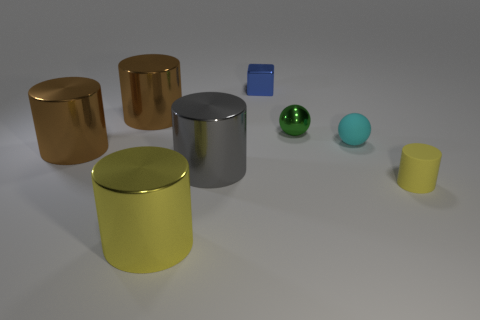Does the yellow object on the right side of the blue metallic object have the same size as the gray metal object to the left of the small green ball?
Your answer should be very brief. No. Are there any yellow cylinders that have the same size as the gray shiny cylinder?
Your answer should be very brief. Yes. Do the brown metal thing that is behind the tiny matte ball and the tiny cyan thing have the same shape?
Offer a terse response. No. There is a yellow cylinder that is right of the tiny green shiny sphere; what is it made of?
Ensure brevity in your answer.  Rubber. What is the shape of the tiny matte object behind the large brown metallic thing that is in front of the green thing?
Your answer should be compact. Sphere. Do the green metal object and the rubber object behind the small yellow rubber object have the same shape?
Ensure brevity in your answer.  Yes. There is a large brown metal cylinder that is behind the green sphere; what number of gray things are behind it?
Provide a succinct answer. 0. What is the material of the big yellow object that is the same shape as the gray shiny object?
Ensure brevity in your answer.  Metal. What number of red objects are tiny rubber cylinders or small metallic balls?
Your response must be concise. 0. Is there any other thing of the same color as the small cylinder?
Provide a short and direct response. Yes. 